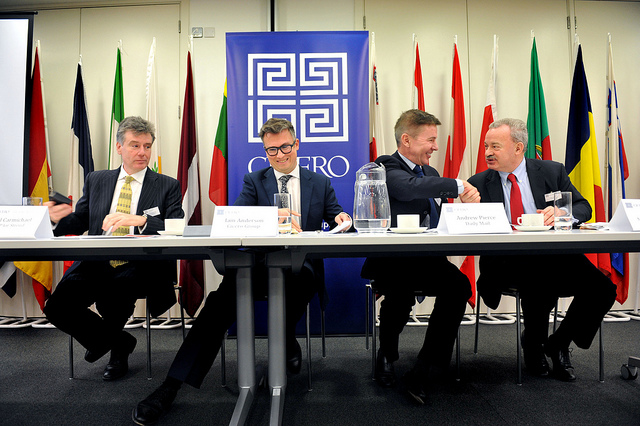Please transcribe the text information in this image. C 